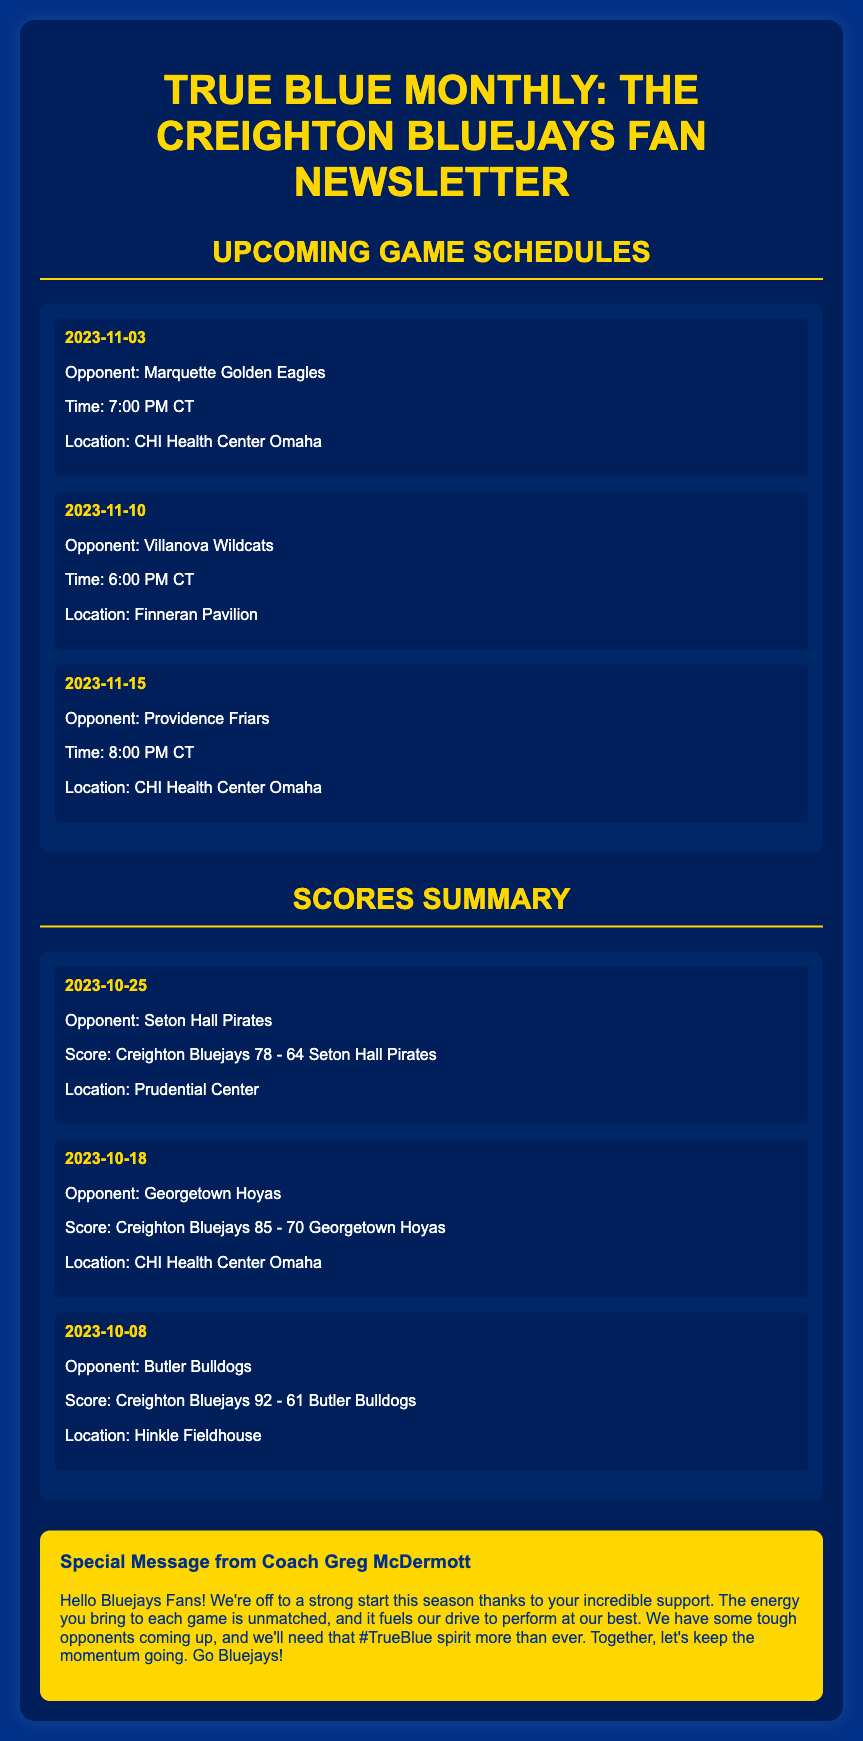What is the title of the newsletter? The title of the newsletter is prominently displayed at the top of the document.
Answer: True Blue Monthly: The Creighton Bluejays Fan Newsletter Who is the opponent on November 10, 2023? The opponent for the game on this date can be found in the upcoming game schedules section.
Answer: Villanova Wildcats What was the score of the game against Seton Hall Pirates? This information is detailed in the scores summary section, listing the teams and their scores.
Answer: Creighton Bluejays 78 - 64 Seton Hall Pirates What date is the game against Providence Friars scheduled? The date of this game is mentioned in the upcoming game schedules section.
Answer: 2023-11-15 What special message does Coach Greg McDermott convey? The message from Coach Greg McDermott summarizes the team's spirit and upcoming challenges.
Answer: Together, let's keep the momentum going. Go Bluejays! How many points did the Bluejays score against Butler Bulldogs? This score can be found in the scores summary section under their match against Butler Bulldogs.
Answer: 92 What is the location of the game against Marquette Golden Eagles? The location of the game is specified in the upcoming game schedules section.
Answer: CHI Health Center Omaha What is the highlighted theme of the newsletter? The overall theme can be discerned from the title or any recurring messages in the document.
Answer: TrueBlue spirit 